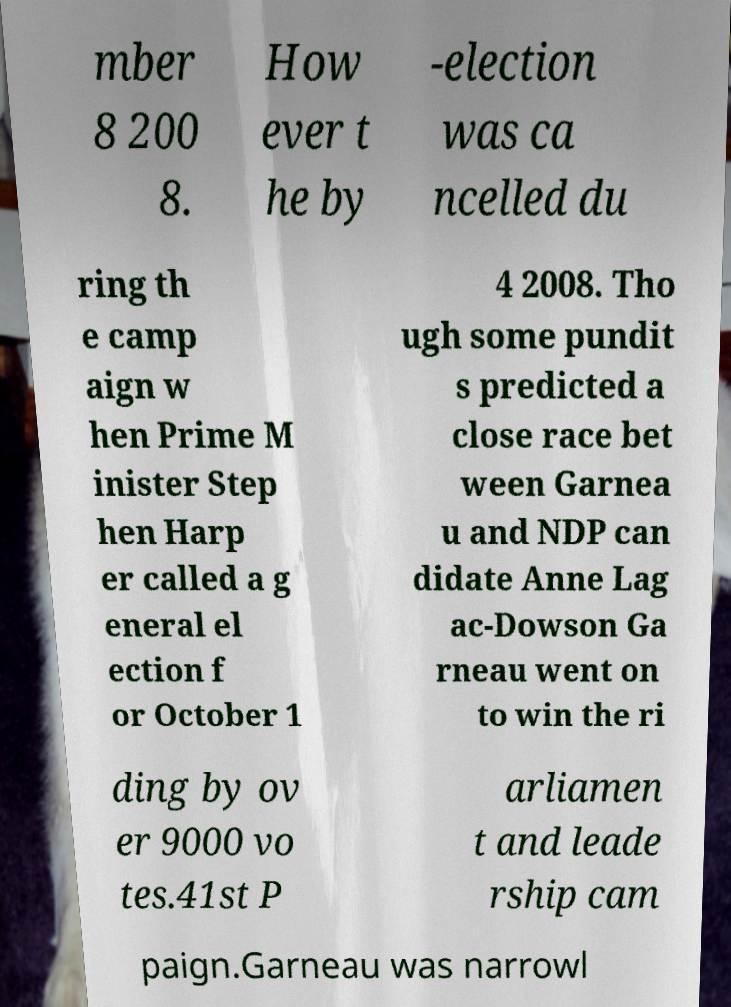There's text embedded in this image that I need extracted. Can you transcribe it verbatim? mber 8 200 8. How ever t he by -election was ca ncelled du ring th e camp aign w hen Prime M inister Step hen Harp er called a g eneral el ection f or October 1 4 2008. Tho ugh some pundit s predicted a close race bet ween Garnea u and NDP can didate Anne Lag ac-Dowson Ga rneau went on to win the ri ding by ov er 9000 vo tes.41st P arliamen t and leade rship cam paign.Garneau was narrowl 